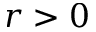<formula> <loc_0><loc_0><loc_500><loc_500>r > 0</formula> 